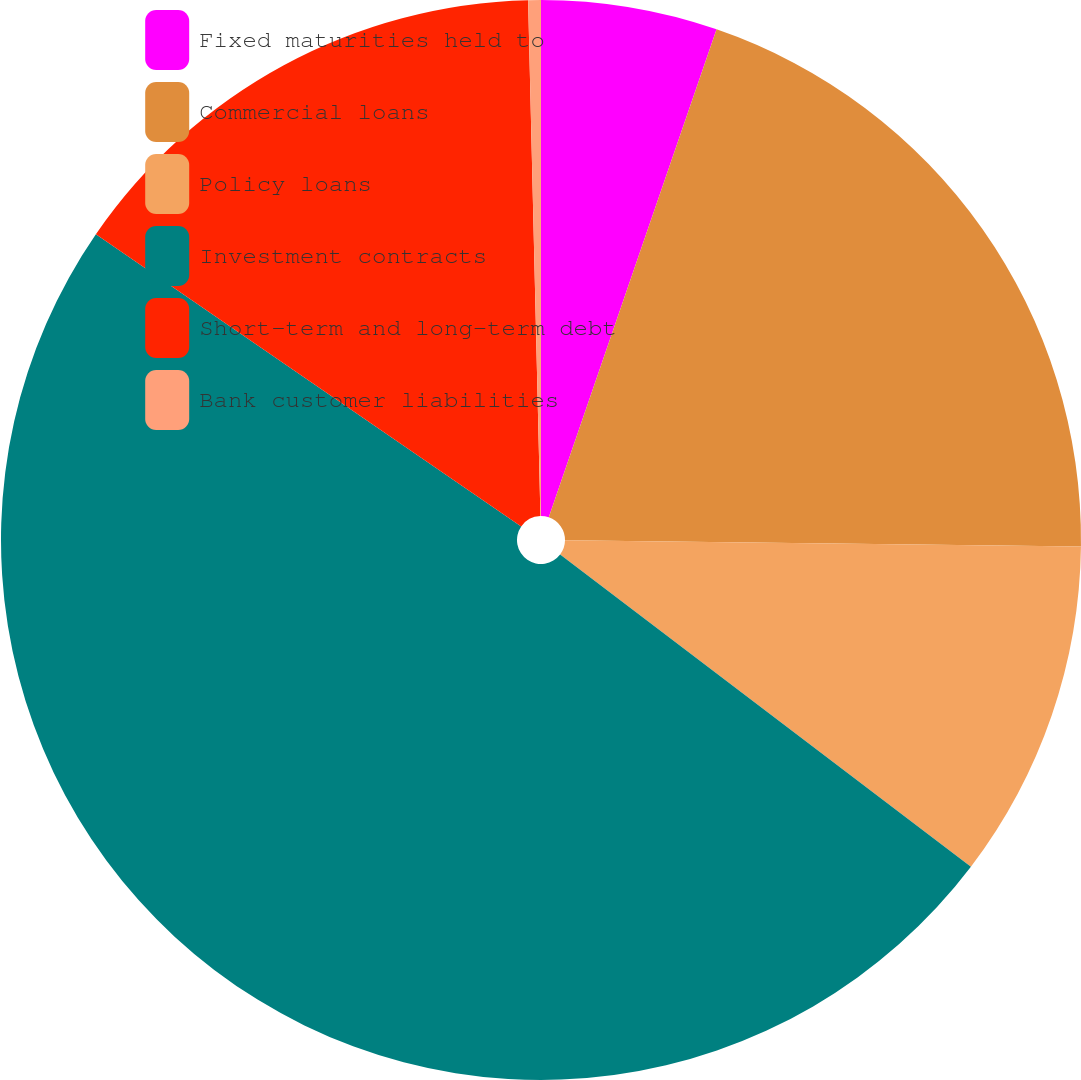Convert chart. <chart><loc_0><loc_0><loc_500><loc_500><pie_chart><fcel>Fixed maturities held to<fcel>Commercial loans<fcel>Policy loans<fcel>Investment contracts<fcel>Short-term and long-term debt<fcel>Bank customer liabilities<nl><fcel>5.27%<fcel>19.92%<fcel>10.15%<fcel>49.23%<fcel>15.04%<fcel>0.38%<nl></chart> 